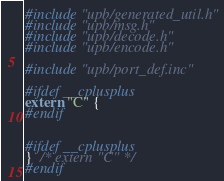Convert code to text. <code><loc_0><loc_0><loc_500><loc_500><_C_>
#include "upb/generated_util.h"
#include "upb/msg.h"
#include "upb/decode.h"
#include "upb/encode.h"

#include "upb/port_def.inc"

#ifdef __cplusplus
extern "C" {
#endif


#ifdef __cplusplus
}  /* extern "C" */
#endif
</code> 